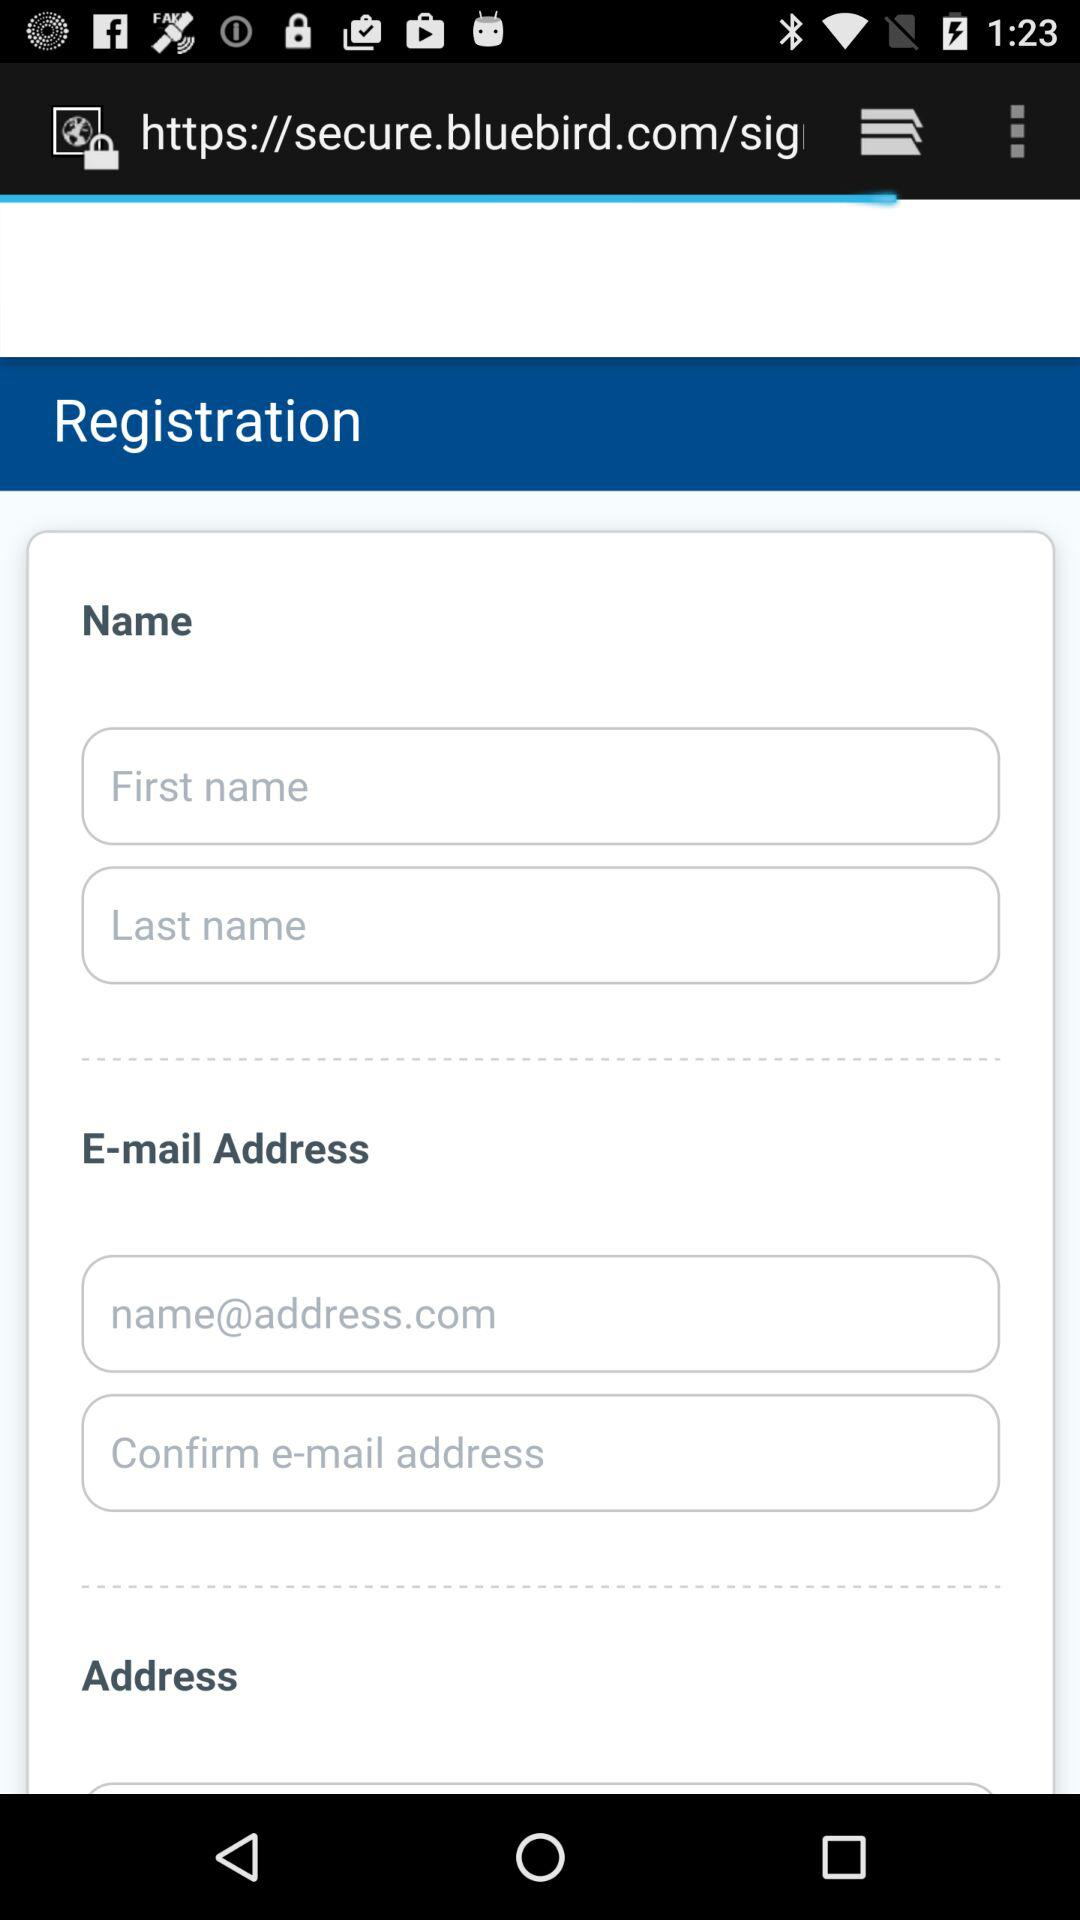How many text inputs are there for email addresses?
Answer the question using a single word or phrase. 2 